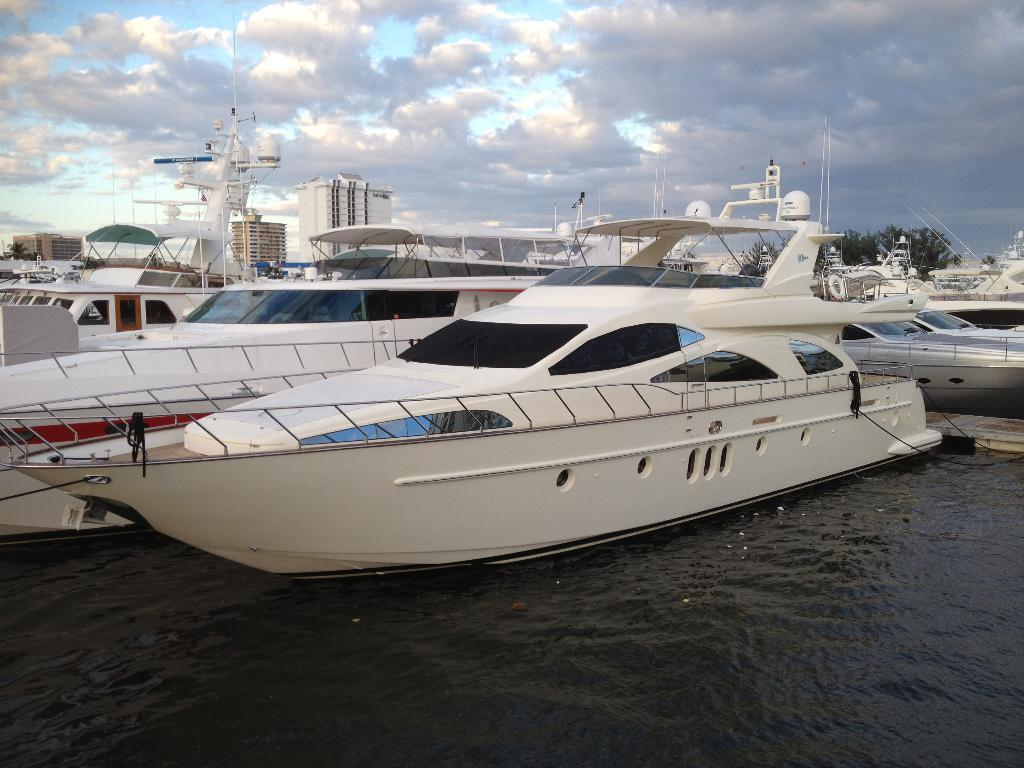What is positioned above the water in the image? There are boats above the water in the image. What structures can be seen in the image? Poles are visible in the image. What can be seen in the distance in the image? There are buildings, trees, and the sky visible in the background of the image. What is the condition of the sky in the image? Clouds are present in the sky in the image. What type of rake is being used to gather clouds in the image? There is no rake present in the image, and clouds are not being gathered. Is there a cart visible in the image? No, there is no cart present in the image. 